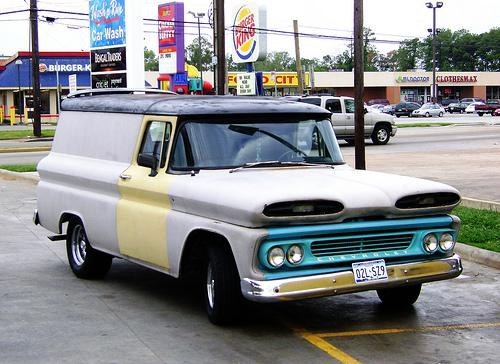Question: how many business signs are in the background?
Choices:
A. Four.
B. Ten.
C. Six.
D. Eight.
Answer with the letter. Answer: B Question: what is the fast food restaurant in the background?
Choices:
A. Burger King.
B. McDonalds.
C. Pizza inn.
D. Dunkin Donuts.
Answer with the letter. Answer: A Question: when was the photo taken?
Choices:
A. Evening.
B. Afternoon.
C. Morning.
D. Night.
Answer with the letter. Answer: B Question: what kind of vehicle is that?
Choices:
A. Mercedes Benz.
B. Limousine.
C. Minivan.
D. Vintage Chevrolet truck.
Answer with the letter. Answer: D Question: where was the photo taken?
Choices:
A. Beach.
B. Park.
C. Parking lot.
D. Street.
Answer with the letter. Answer: C Question: how many round headlights does the truck have?
Choices:
A. Two.
B. Four.
C. Six.
D. Eight.
Answer with the letter. Answer: B 